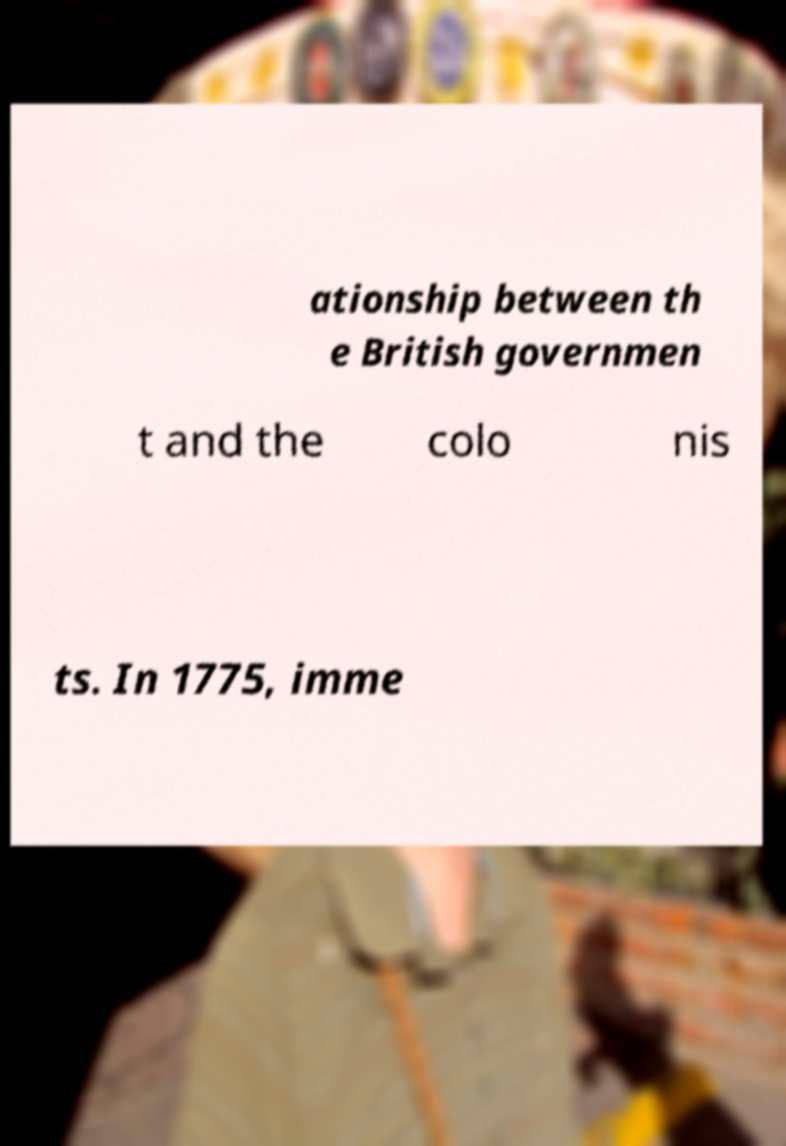Can you accurately transcribe the text from the provided image for me? ationship between th e British governmen t and the colo nis ts. In 1775, imme 